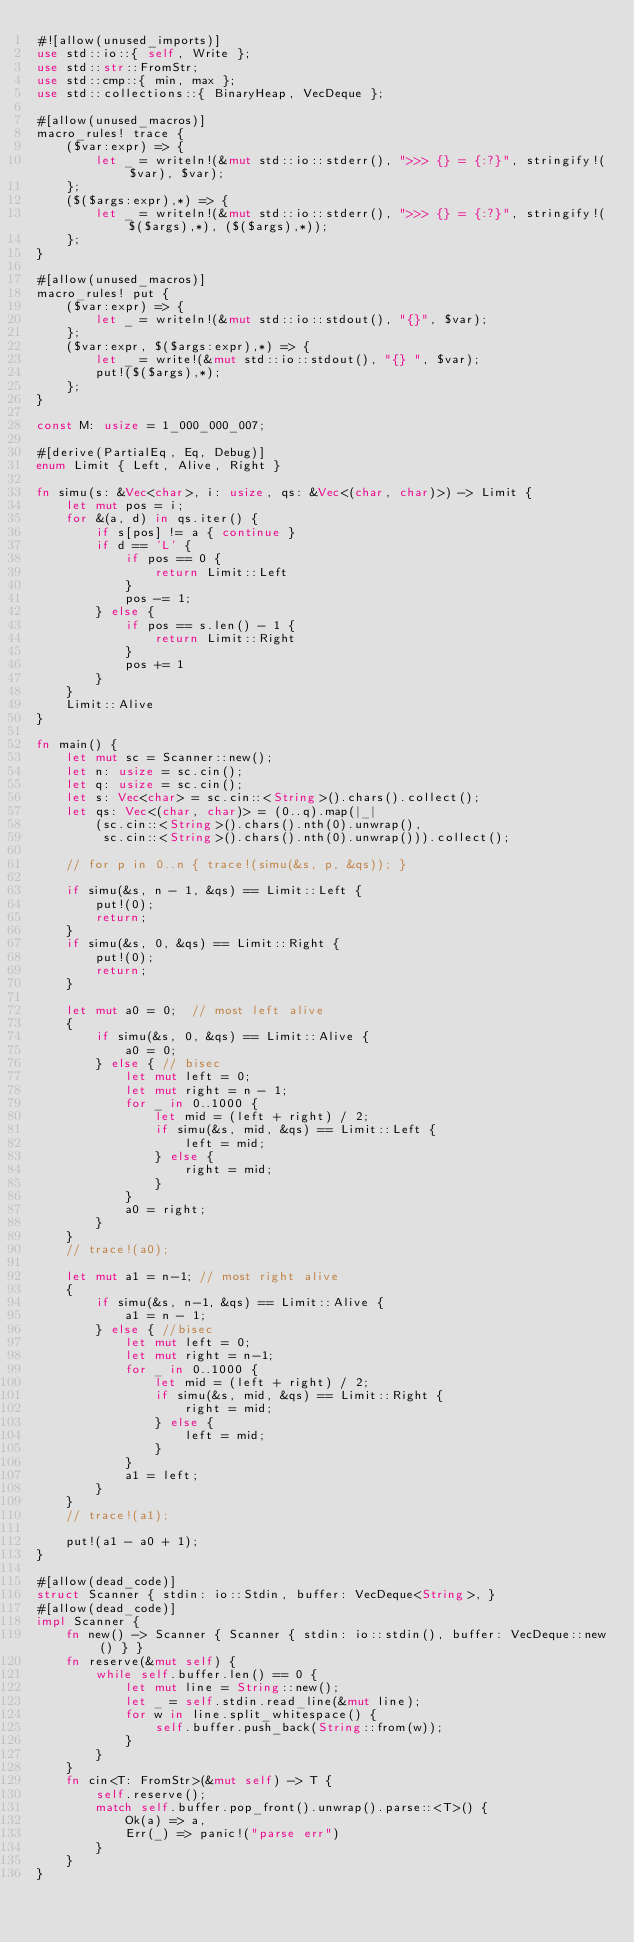<code> <loc_0><loc_0><loc_500><loc_500><_Rust_>#![allow(unused_imports)]
use std::io::{ self, Write };
use std::str::FromStr;
use std::cmp::{ min, max };
use std::collections::{ BinaryHeap, VecDeque };

#[allow(unused_macros)]
macro_rules! trace {
    ($var:expr) => {
        let _ = writeln!(&mut std::io::stderr(), ">>> {} = {:?}", stringify!($var), $var);
    };
    ($($args:expr),*) => {
        let _ = writeln!(&mut std::io::stderr(), ">>> {} = {:?}", stringify!($($args),*), ($($args),*));
    };
}

#[allow(unused_macros)]
macro_rules! put {
    ($var:expr) => {
        let _ = writeln!(&mut std::io::stdout(), "{}", $var);
    };
    ($var:expr, $($args:expr),*) => {
        let _ = write!(&mut std::io::stdout(), "{} ", $var);
        put!($($args),*);
    };
}

const M: usize = 1_000_000_007;

#[derive(PartialEq, Eq, Debug)]
enum Limit { Left, Alive, Right }

fn simu(s: &Vec<char>, i: usize, qs: &Vec<(char, char)>) -> Limit {
    let mut pos = i;
    for &(a, d) in qs.iter() {
        if s[pos] != a { continue }
        if d == 'L' {
            if pos == 0 {
                return Limit::Left
            }
            pos -= 1;
        } else {
            if pos == s.len() - 1 {
                return Limit::Right
            }
            pos += 1
        }
    }
    Limit::Alive
}

fn main() {
    let mut sc = Scanner::new();
    let n: usize = sc.cin();
    let q: usize = sc.cin();
    let s: Vec<char> = sc.cin::<String>().chars().collect();
    let qs: Vec<(char, char)> = (0..q).map(|_|
        (sc.cin::<String>().chars().nth(0).unwrap(),
         sc.cin::<String>().chars().nth(0).unwrap())).collect();

    // for p in 0..n { trace!(simu(&s, p, &qs)); }

    if simu(&s, n - 1, &qs) == Limit::Left {
        put!(0);
        return;
    }
    if simu(&s, 0, &qs) == Limit::Right {
        put!(0);
        return;
    }

    let mut a0 = 0;  // most left alive
    {
        if simu(&s, 0, &qs) == Limit::Alive {
            a0 = 0;
        } else { // bisec
            let mut left = 0;
            let mut right = n - 1;
            for _ in 0..1000 {
                let mid = (left + right) / 2;
                if simu(&s, mid, &qs) == Limit::Left {
                    left = mid;
                } else {
                    right = mid;
                }
            }
            a0 = right;
        }
    }
    // trace!(a0);

    let mut a1 = n-1; // most right alive
    {
        if simu(&s, n-1, &qs) == Limit::Alive {
            a1 = n - 1;
        } else { //bisec
            let mut left = 0;
            let mut right = n-1;
            for _ in 0..1000 {
                let mid = (left + right) / 2;
                if simu(&s, mid, &qs) == Limit::Right {
                    right = mid;
                } else {
                    left = mid;
                }
            }
            a1 = left;
        }
    }
    // trace!(a1);

    put!(a1 - a0 + 1);
}

#[allow(dead_code)]
struct Scanner { stdin: io::Stdin, buffer: VecDeque<String>, }
#[allow(dead_code)]
impl Scanner {
    fn new() -> Scanner { Scanner { stdin: io::stdin(), buffer: VecDeque::new() } }
    fn reserve(&mut self) {
        while self.buffer.len() == 0 {
            let mut line = String::new();
            let _ = self.stdin.read_line(&mut line);
            for w in line.split_whitespace() {
                self.buffer.push_back(String::from(w));
            }
        }
    }
    fn cin<T: FromStr>(&mut self) -> T {
        self.reserve();
        match self.buffer.pop_front().unwrap().parse::<T>() {
            Ok(a) => a,
            Err(_) => panic!("parse err")
        }
    }
}
</code> 